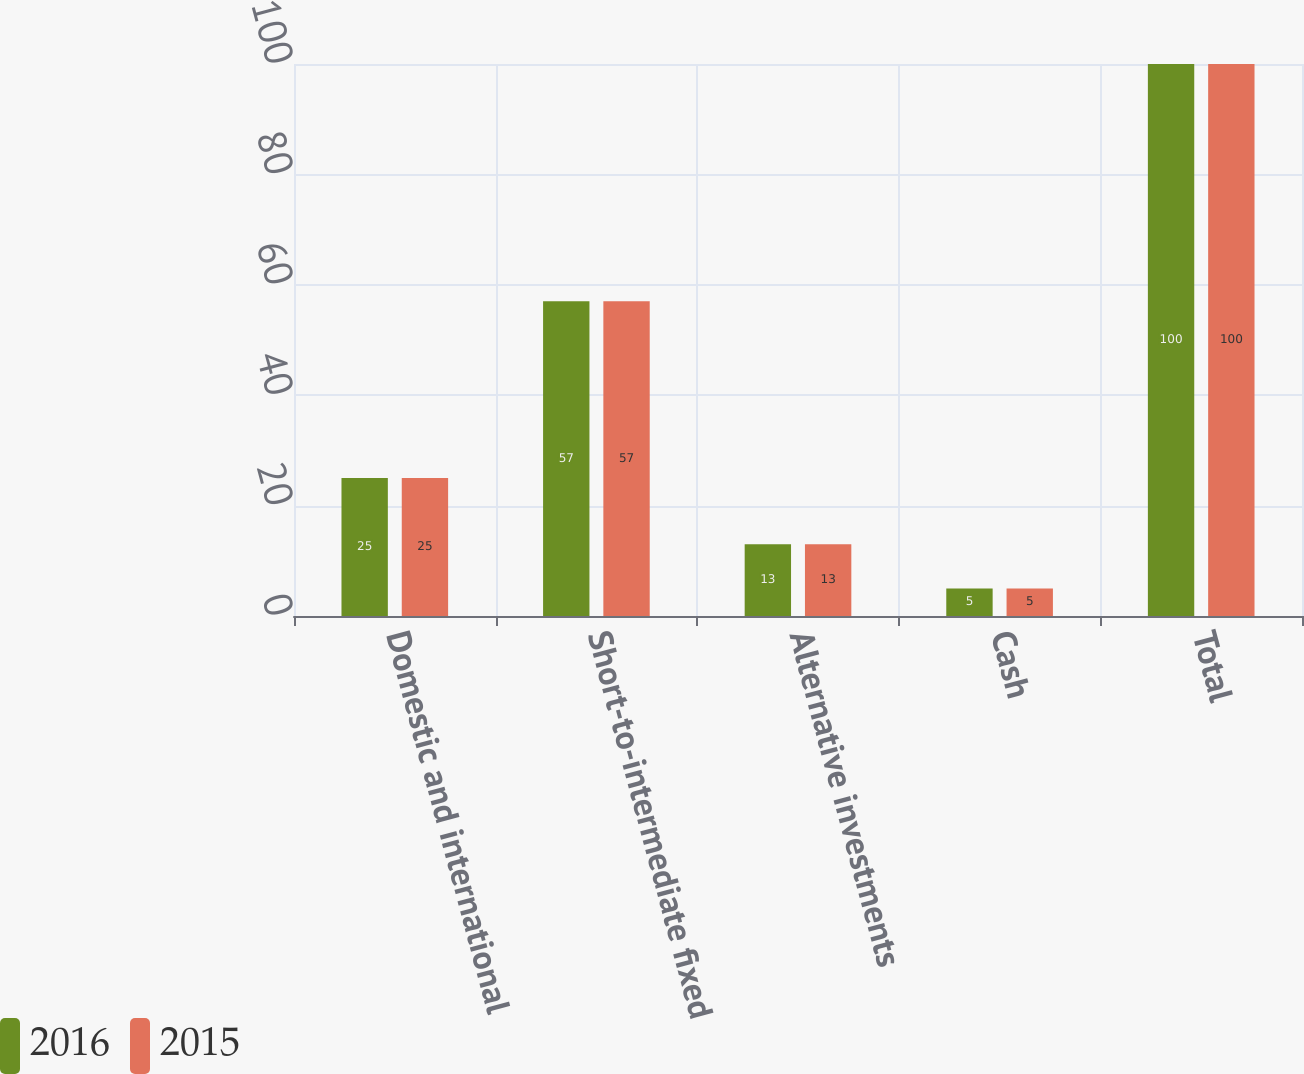Convert chart to OTSL. <chart><loc_0><loc_0><loc_500><loc_500><stacked_bar_chart><ecel><fcel>Domestic and international<fcel>Short-to-intermediate fixed<fcel>Alternative investments<fcel>Cash<fcel>Total<nl><fcel>2016<fcel>25<fcel>57<fcel>13<fcel>5<fcel>100<nl><fcel>2015<fcel>25<fcel>57<fcel>13<fcel>5<fcel>100<nl></chart> 